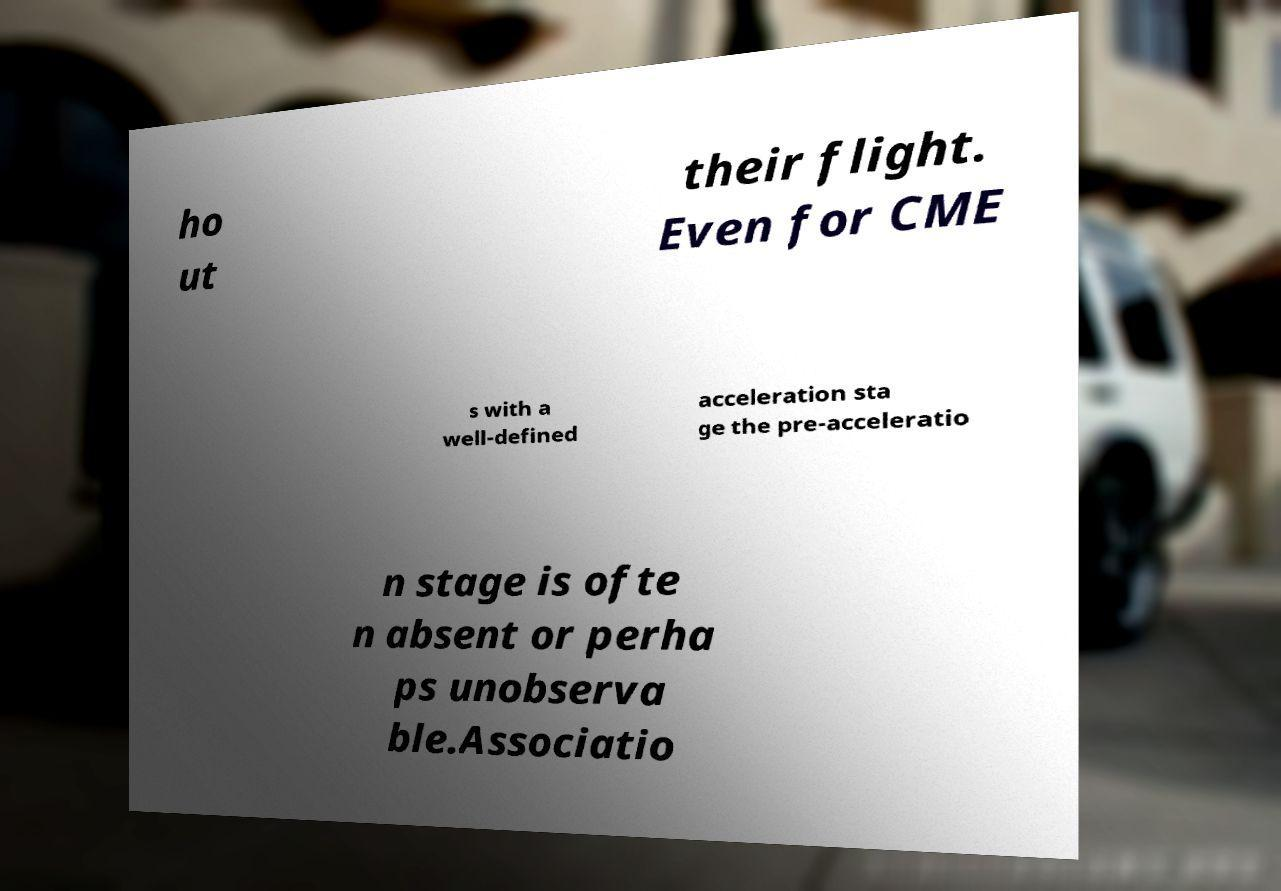Could you extract and type out the text from this image? ho ut their flight. Even for CME s with a well-defined acceleration sta ge the pre-acceleratio n stage is ofte n absent or perha ps unobserva ble.Associatio 